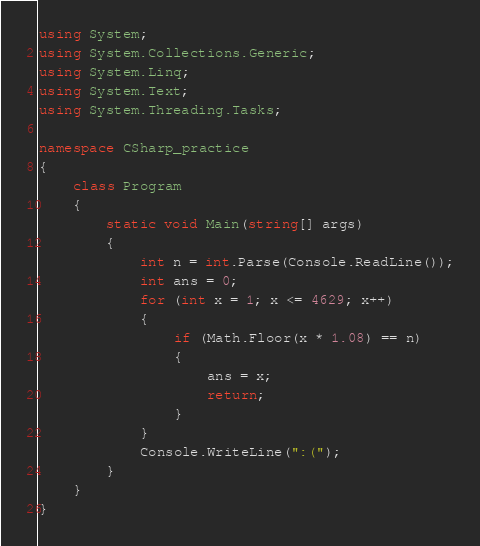<code> <loc_0><loc_0><loc_500><loc_500><_C#_>using System;
using System.Collections.Generic;
using System.Linq;
using System.Text;
using System.Threading.Tasks;

namespace CSharp_practice
{
    class Program
    {
        static void Main(string[] args)
        {
            int n = int.Parse(Console.ReadLine());
            int ans = 0;
            for (int x = 1; x <= 4629; x++)
            {
                if (Math.Floor(x * 1.08) == n)
                {
                    ans = x;
                    return;
                }
            }
            Console.WriteLine(":(");
        }
    }
}
</code> 